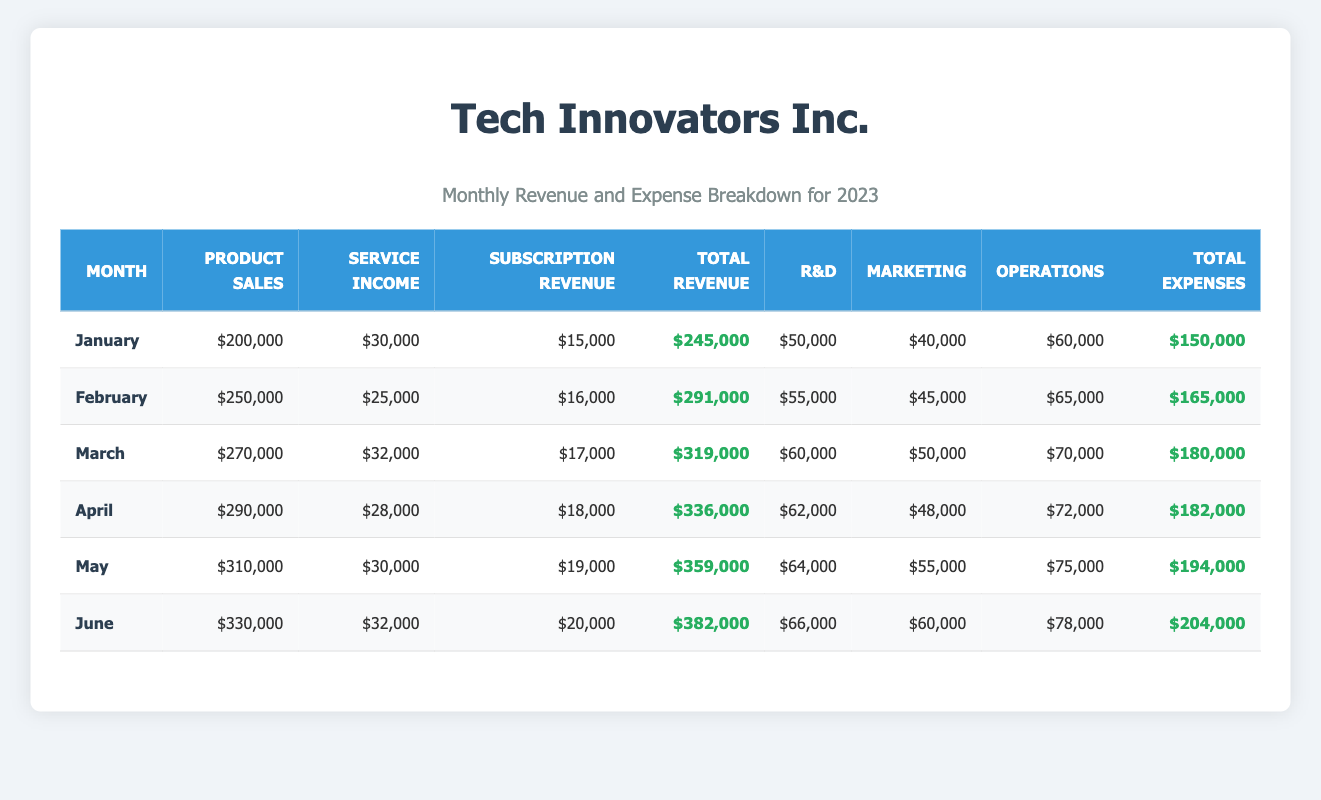What was the total revenue for March? In the March row, the "Total Revenue" column shows a value of $319,000.
Answer: $319,000 What was the total expense for April? In the April row, the "Total Expenses" column indicates the total expenses were $182,000.
Answer: $182,000 Which month had the highest product sales? By comparing the "Product Sales" column across all months, June has the highest value at $330,000.
Answer: June What is the average total revenue from January to June? The total revenues for January through June are $245,000, $291,000, $319,000, $336,000, $359,000, and $382,000. Summing these values gives $1,932,000. Dividing by 6 months yields an average of $1,932,000 / 6 = $322,000.
Answer: $322,000 Was the total income greater than the total expenses in every month? In every month's row, the "Total Revenue" exceeds the "Total Expenses". For instance, in January, total revenue was $245,000 and total expenses were $150,000, indicating the income was greater. This pattern is consistent for all months.
Answer: Yes Which month had the largest increase in total revenue compared to the previous month? The increases in total revenue from month to month can be calculated: January to February ($291,000 - $245,000 = $46,000), February to March ($319,000 - $291,000 = $28,000), March to April ($336,000 - $319,000 = $17,000), April to May ($359,000 - $336,000 = $23,000), May to June ($382,000 - $359,000 = $23,000). The largest increase was from January to February with a difference of $46,000.
Answer: January to February What percentage of total expenses was spent on R&D in May? In May, total expenses were $194,000 and spending on R&D was $64,000. To find the percentage, calculate (64,000 / 194,000) * 100 = 32.99%, which can be approximated to 33%.
Answer: 33% How much did the total expenses increase from January to June? The total expense for January was $150,000 and for June was $204,000. The increase can be calculated as $204,000 - $150,000 = $54,000.
Answer: $54,000 Was the expenditures on marketing in June greater than the average marketing expenditures from January to May? The marketing expenses from January to May are $40,000, $45,000, $50,000, $48,000, and $55,000, totaling $238,000. Dividing by 5 gives an average of $47,600. In June, expenditure on marketing was $60,000, which is greater than $47,600.
Answer: Yes 